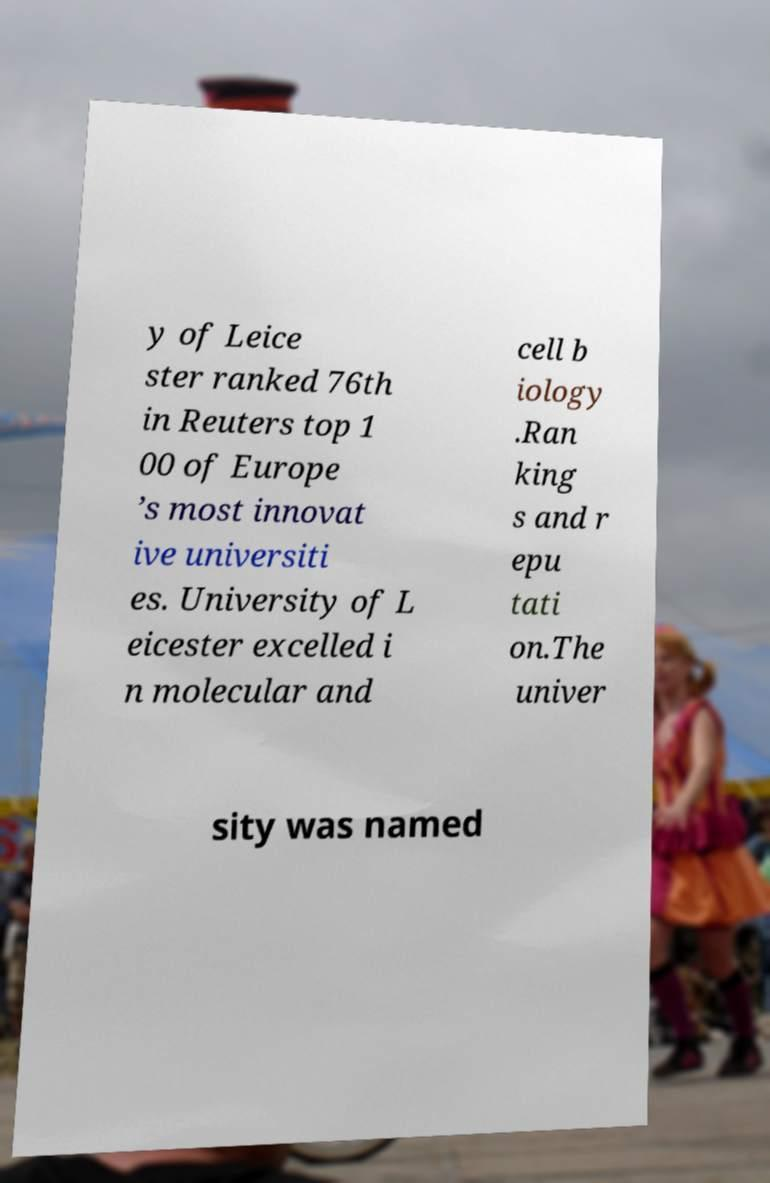For documentation purposes, I need the text within this image transcribed. Could you provide that? y of Leice ster ranked 76th in Reuters top 1 00 of Europe ’s most innovat ive universiti es. University of L eicester excelled i n molecular and cell b iology .Ran king s and r epu tati on.The univer sity was named 